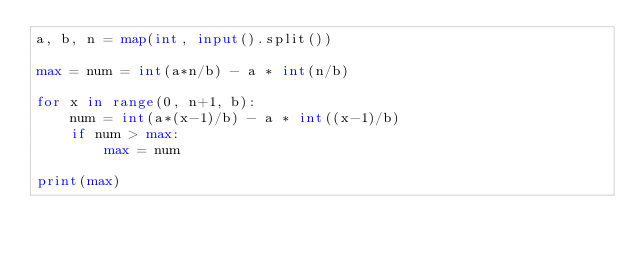<code> <loc_0><loc_0><loc_500><loc_500><_Python_>a, b, n = map(int, input().split())

max = num = int(a*n/b) - a * int(n/b)

for x in range(0, n+1, b):
    num = int(a*(x-1)/b) - a * int((x-1)/b)
    if num > max:
        max = num

print(max)
</code> 